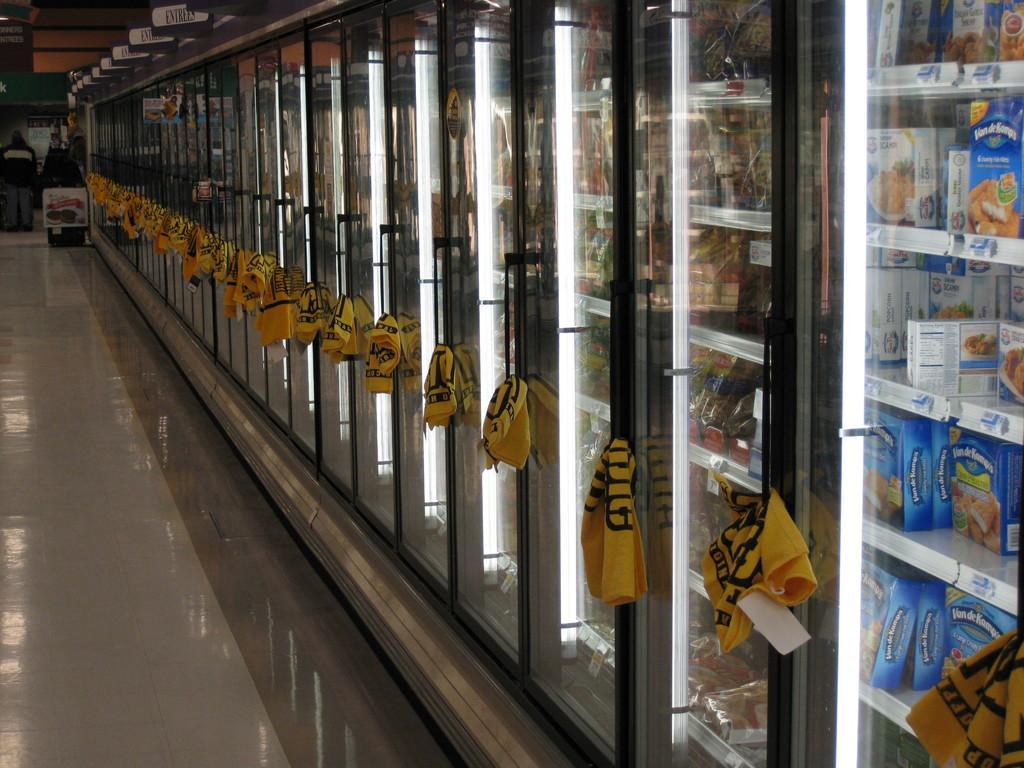Could you give a brief overview of what you see in this image? In this image we can see some fridges, we can see some boxes and other food item in fridges, there are some clothes on the handles, also we can see a board with some text written on it, and we can see the roof. 